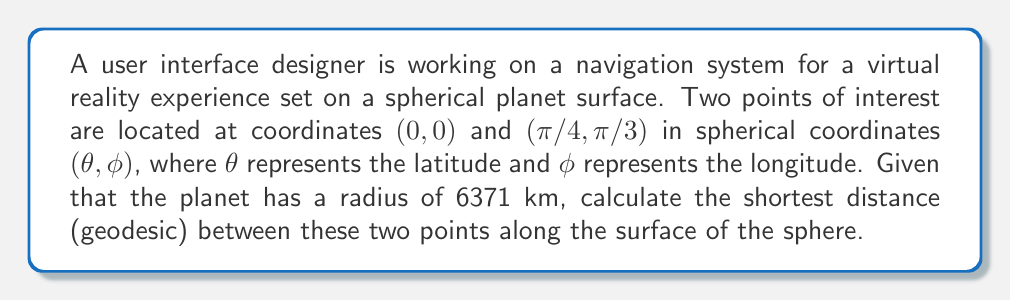Teach me how to tackle this problem. To solve this problem, we'll use the formula for geodesic distance on a sphere, also known as the great-circle distance. The steps are as follows:

1) First, recall the formula for geodesic distance on a sphere:

   $$d = R \cdot \arccos(\sin θ_1 \sin θ_2 + \cos θ_1 \cos θ_2 \cos(φ_2 - φ_1))$$

   Where:
   - $R$ is the radius of the sphere
   - $(θ_1, φ_1)$ are the latitude and longitude of the first point
   - $(θ_2, φ_2)$ are the latitude and longitude of the second point

2) We're given:
   - $R = 6371$ km
   - Point 1: $(θ_1, φ_1) = (0, 0)$
   - Point 2: $(θ_2, φ_2) = (π/4, π/3)$

3) Let's substitute these values into the formula:

   $$d = 6371 \cdot \arccos(\sin(0) \sin(π/4) + \cos(0) \cos(π/4) \cos(π/3 - 0))$$

4) Simplify:
   - $\sin(0) = 0$
   - $\cos(0) = 1$
   - $\sin(π/4) = 1/\sqrt{2}$
   - $\cos(π/4) = 1/\sqrt{2}$
   - $\cos(π/3) = 1/2$

   $$d = 6371 \cdot \arccos(0 + (1/\sqrt{2})(1/\sqrt{2})(1/2))$$

5) Simplify further:

   $$d = 6371 \cdot \arccos(1/4)$$

6) Calculate the final result:

   $$d ≈ 6371 \cdot 1.3181 ≈ 8397.6 \text{ km}$$

This geodesic distance represents the shortest path between the two points along the surface of the sphere.
Answer: The geodesic distance between the two points is approximately 8397.6 km. 